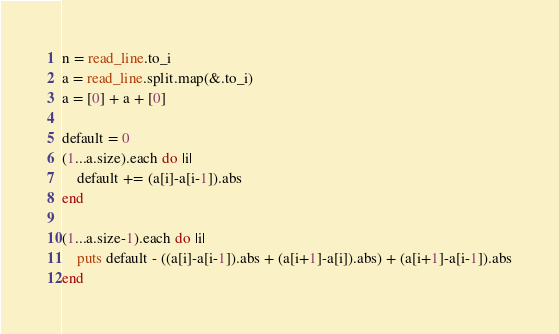<code> <loc_0><loc_0><loc_500><loc_500><_Crystal_>n = read_line.to_i
a = read_line.split.map(&.to_i)
a = [0] + a + [0]

default = 0
(1...a.size).each do |i|
	default += (a[i]-a[i-1]).abs
end

(1...a.size-1).each do |i|
	puts default - ((a[i]-a[i-1]).abs + (a[i+1]-a[i]).abs) + (a[i+1]-a[i-1]).abs
end
</code> 